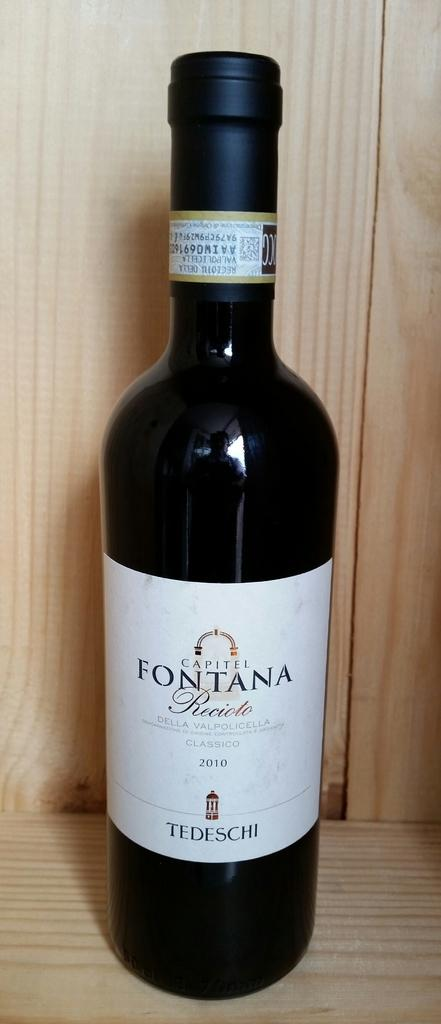<image>
Give a short and clear explanation of the subsequent image. A bottle of Fontana Recioto from 2010 is on a wooden shelf. 